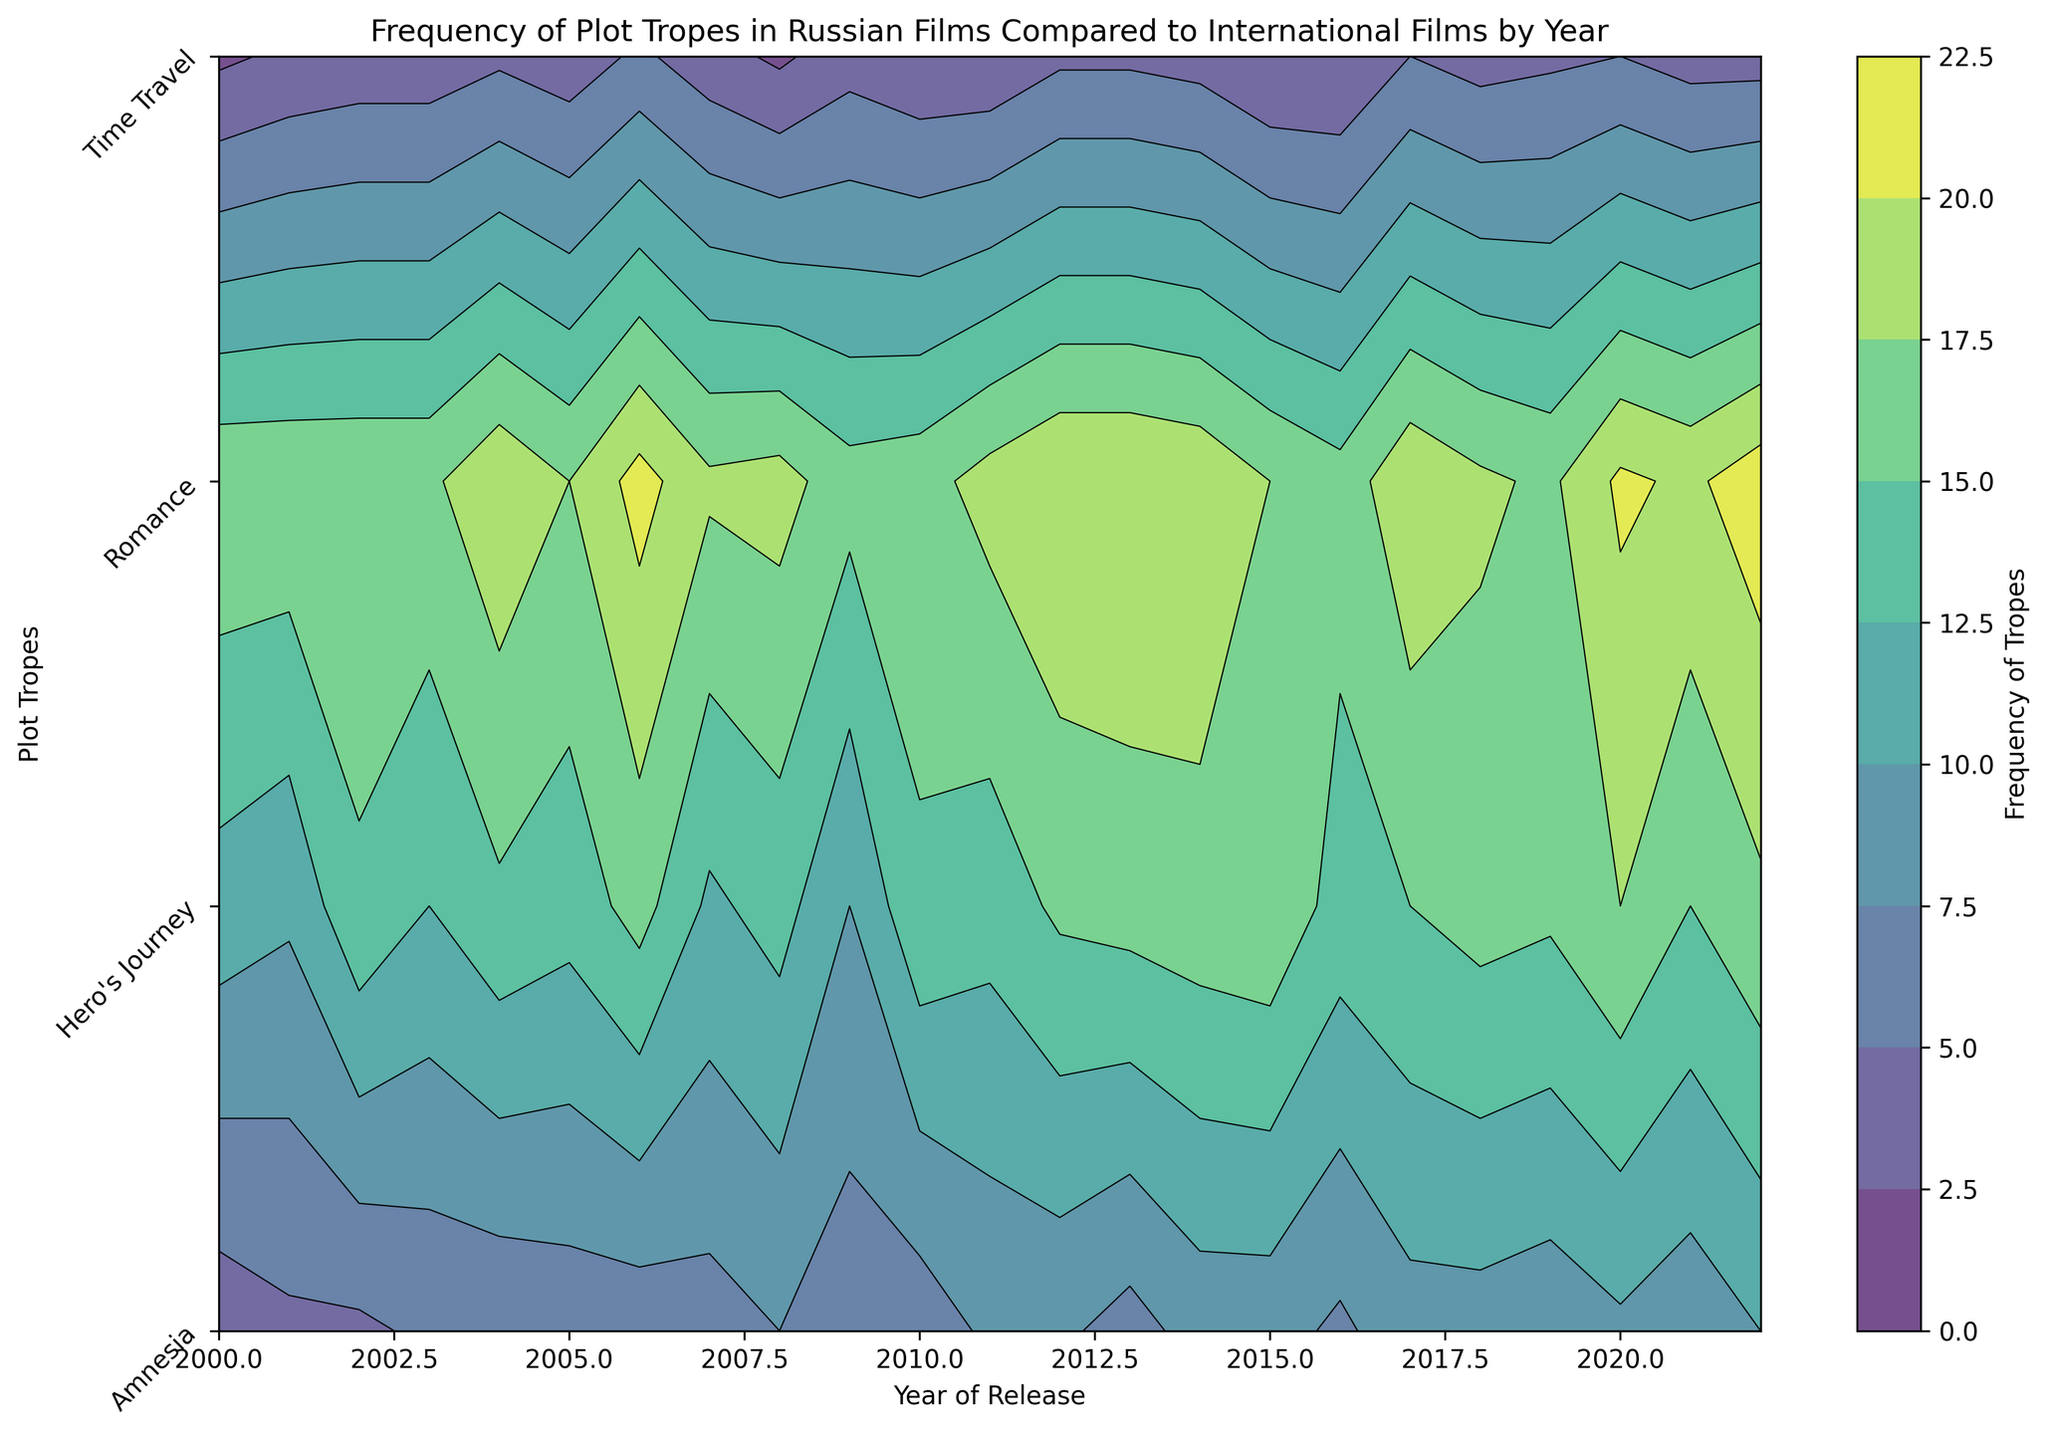What's the most frequent plot trope in 2022? By observing the color gradients, we can determine the highest frequency plot trope. The darkest area in 2022 is adjacent to 'Romance'
Answer: Romance How does the frequency of the 'Hero's Journey' trope in 2018 compare to 2013? Review the contour lines and color intensity for 'Hero's Journey' for both years. 2018 shows lighter shade than 2013, suggesting less frequency
Answer: 2013 is higher Which plot trope saw a significant increase in frequency in Russian films from 2000 to 2022? Look for the gradient shift from a lighter to a darker color for Russian tropes between these years. 'Romance' shows noticeable increase
Answer: Romance Between 'Amnesia' and 'Time Travel', which trope was more common in 2005? Compare the shade gradient for both tropes in 2005. The gradient for 'Time Travel' appears lighter than 'Amnesia'
Answer: Amnesia What was the trend in the frequency of 'Romance' tropes from 2010 to 2022? Evaluate the color gradient for 'Romance' from 2010 to 2022. Observe that the shades consistently get darker
Answer: Increasing Compare the frequency of 'Hero's Journey' trope in Russian vs International films in 2017. Look at the color contrast between international and Russian parts for 'Hero's Journey' in 2017. The Russian shade is much lighter
Answer: International is higher What plot trope had the smallest change in frequency from 2000 to 2022? Observe the contour details for each trope. 'Amnesia' shows the least change in color gradient over the years
Answer: Amnesia In which year did 'Time Travel' in Russian films peak? Identify the darkest shade for 'Time Travel' in Russian films. It peaks around 2020 and 2017 is another significant instance
Answer: 2020 How does the frequency of 'Amnesia' in 2002 compare to 2020? Contrast the color intensity of 'Amnesia' between these years. 2002 has a much lighter shade compared to 2020
Answer: 2020 is higher What is the general trend of 'Romance' tropes in International films from 2005 to 2022? Observe the color gradient for 'Romance' in International parts from 2005 to 2022. Shades consistently get darker
Answer: Increasing 